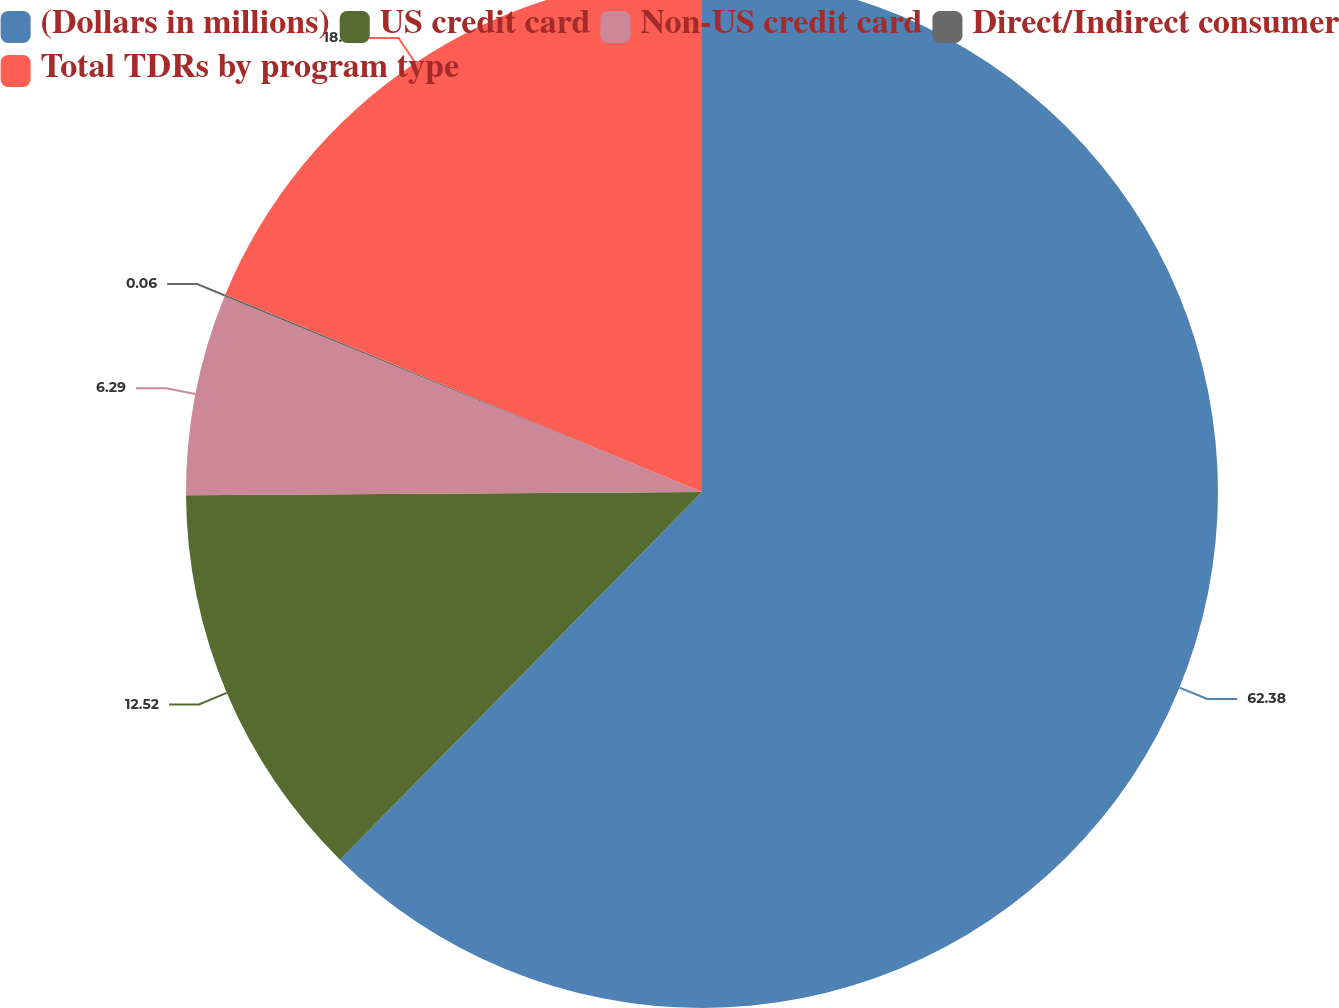Convert chart. <chart><loc_0><loc_0><loc_500><loc_500><pie_chart><fcel>(Dollars in millions)<fcel>US credit card<fcel>Non-US credit card<fcel>Direct/Indirect consumer<fcel>Total TDRs by program type<nl><fcel>62.37%<fcel>12.52%<fcel>6.29%<fcel>0.06%<fcel>18.75%<nl></chart> 